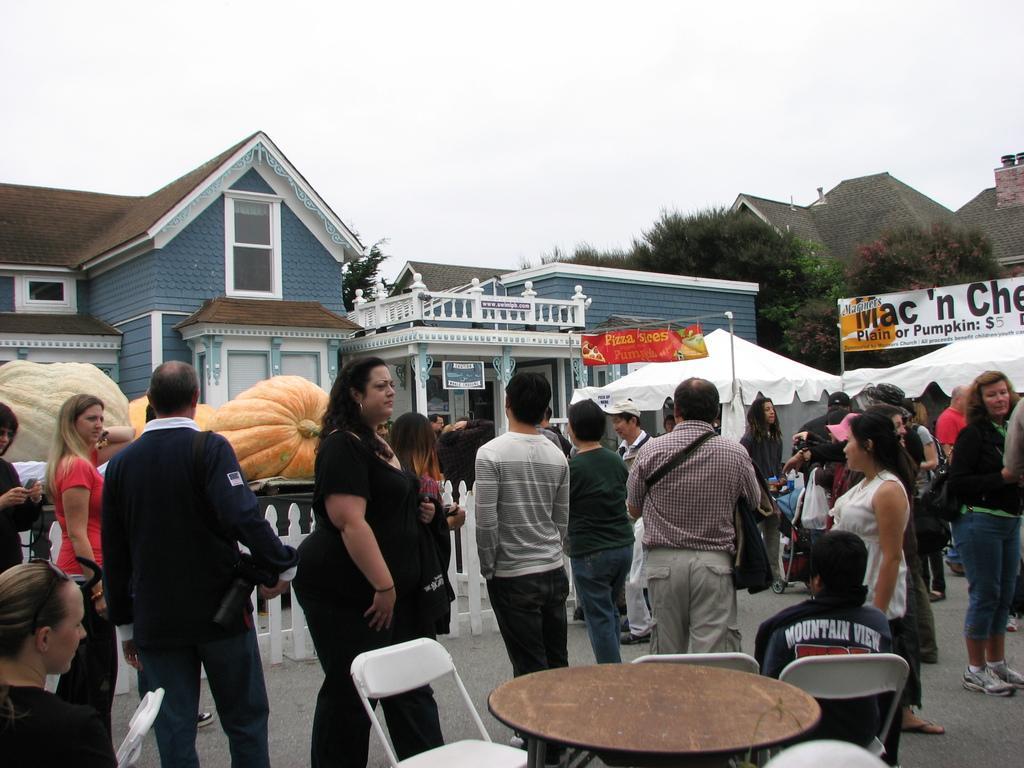Please provide a concise description of this image. Persons are standing. This are chairs and table. Far there are trees and buildings. This house with window and roof top. This are vegetables. This is a fence. This are tents with banners. 